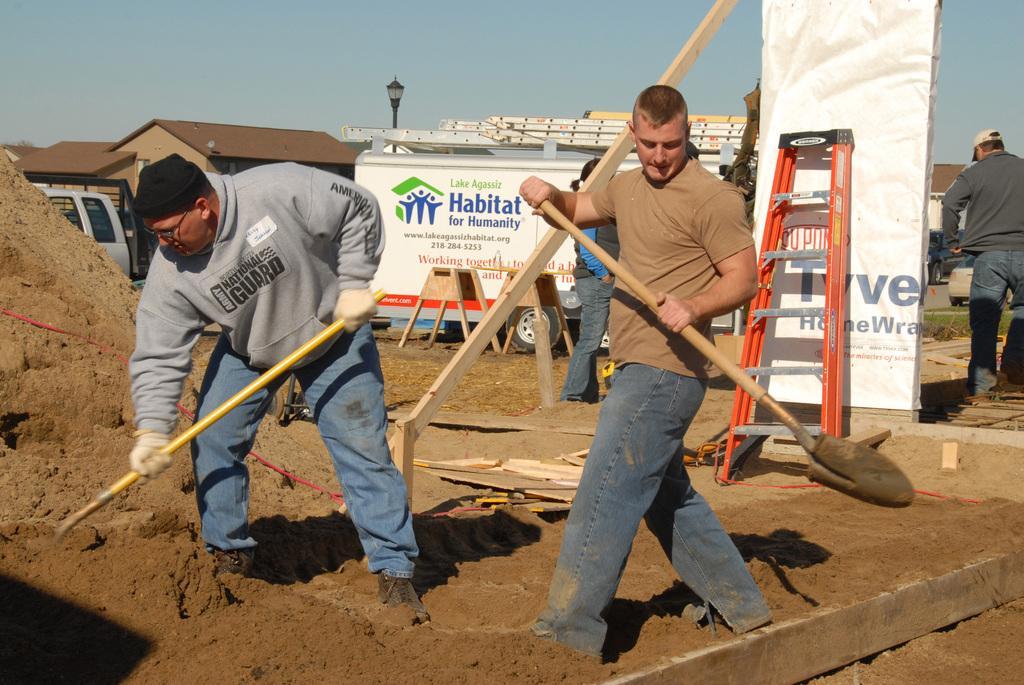In one or two sentences, can you explain what this image depicts? In the foreground of the picture there are men taking sand using shovels and there are some wooden objects also. In the center of the picture there are vehicles, houses, street light, board, ladder, people, grass and various objects. In the background it is sky. 